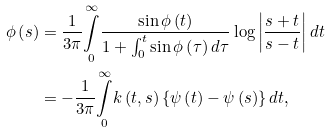Convert formula to latex. <formula><loc_0><loc_0><loc_500><loc_500>\phi \left ( s \right ) & = \frac { 1 } { 3 \pi } \underset { 0 } { \overset { \infty } { \int } } \frac { \sin \phi \left ( t \right ) } { 1 + \int _ { 0 } ^ { t } \sin \phi \left ( \tau \right ) d \tau } \log \left | \frac { s + t } { s - t } \right | d t \\ & = - \frac { 1 } { 3 \pi } \underset { 0 } { \overset { \infty } { \int } } k \left ( t , s \right ) \left \{ \psi \left ( t \right ) - \psi \left ( s \right ) \right \} d t \text {,}</formula> 